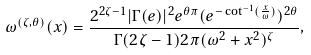<formula> <loc_0><loc_0><loc_500><loc_500>\omega ^ { ( \zeta , \theta ) } ( x ) = \frac { 2 ^ { 2 \zeta - 1 } | \Gamma ( e ) | ^ { 2 } e ^ { \theta \pi } ( e ^ { - \cot ^ { - 1 } ( \frac { x } { \omega } ) } ) ^ { 2 \theta } } { \Gamma ( 2 \zeta - 1 ) 2 \pi ( \omega ^ { 2 } + x ^ { 2 } ) ^ { \zeta } } ,</formula> 